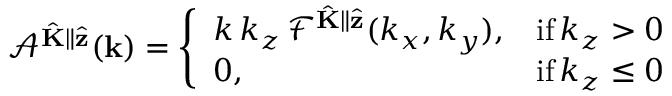Convert formula to latex. <formula><loc_0><loc_0><loc_500><loc_500>\mathcal { A } ^ { \hat { K } \| \hat { z } } ( k ) = \left \{ \begin{array} { l l } { k \, k _ { z } \, \mathcal { F } ^ { \hat { K } \| \hat { z } } ( k _ { x } , k _ { y } ) , } & { i f \, k _ { z } > 0 } \\ { 0 , } & { i f \, k _ { z } \leq 0 } \end{array}</formula> 